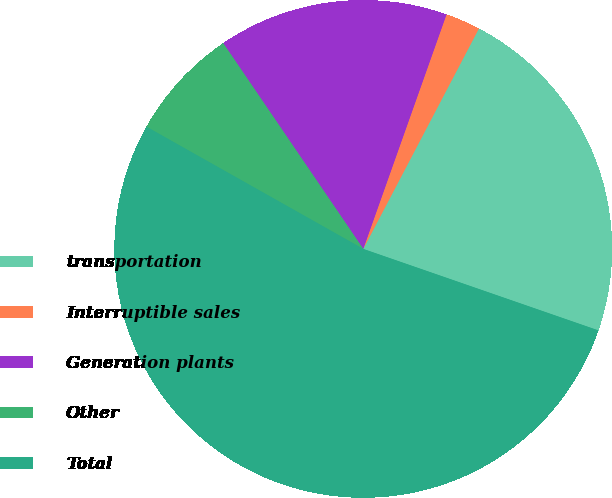<chart> <loc_0><loc_0><loc_500><loc_500><pie_chart><fcel>transportation<fcel>Interruptible sales<fcel>Generation plants<fcel>Other<fcel>Total<nl><fcel>22.62%<fcel>2.26%<fcel>14.94%<fcel>7.32%<fcel>52.86%<nl></chart> 